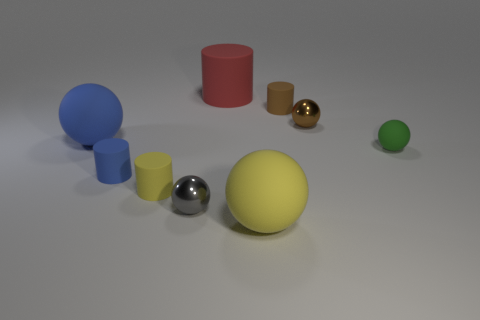How many other objects are there of the same material as the green ball?
Offer a very short reply. 6. There is a big thing that is in front of the tiny green thing; is its color the same as the cylinder that is in front of the small blue rubber object?
Keep it short and to the point. Yes. Are there fewer small green matte objects than blue objects?
Your answer should be very brief. Yes. There is a tiny rubber object that is behind the thing that is to the right of the tiny brown metallic sphere; what is its shape?
Make the answer very short. Cylinder. There is a small metal thing on the right side of the large ball that is in front of the blue rubber thing that is in front of the small green matte sphere; what is its shape?
Offer a terse response. Sphere. How many objects are matte spheres on the left side of the small green sphere or tiny cylinders in front of the green ball?
Give a very brief answer. 4. Is the size of the yellow rubber ball the same as the red thing that is behind the yellow cylinder?
Keep it short and to the point. Yes. Are the large thing that is behind the tiny brown shiny object and the small ball that is to the left of the large matte cylinder made of the same material?
Provide a short and direct response. No. Is the number of tiny yellow cylinders that are in front of the small yellow matte cylinder the same as the number of big balls in front of the tiny brown rubber cylinder?
Ensure brevity in your answer.  No. What number of rubber objects are big yellow things or red objects?
Provide a succinct answer. 2. 